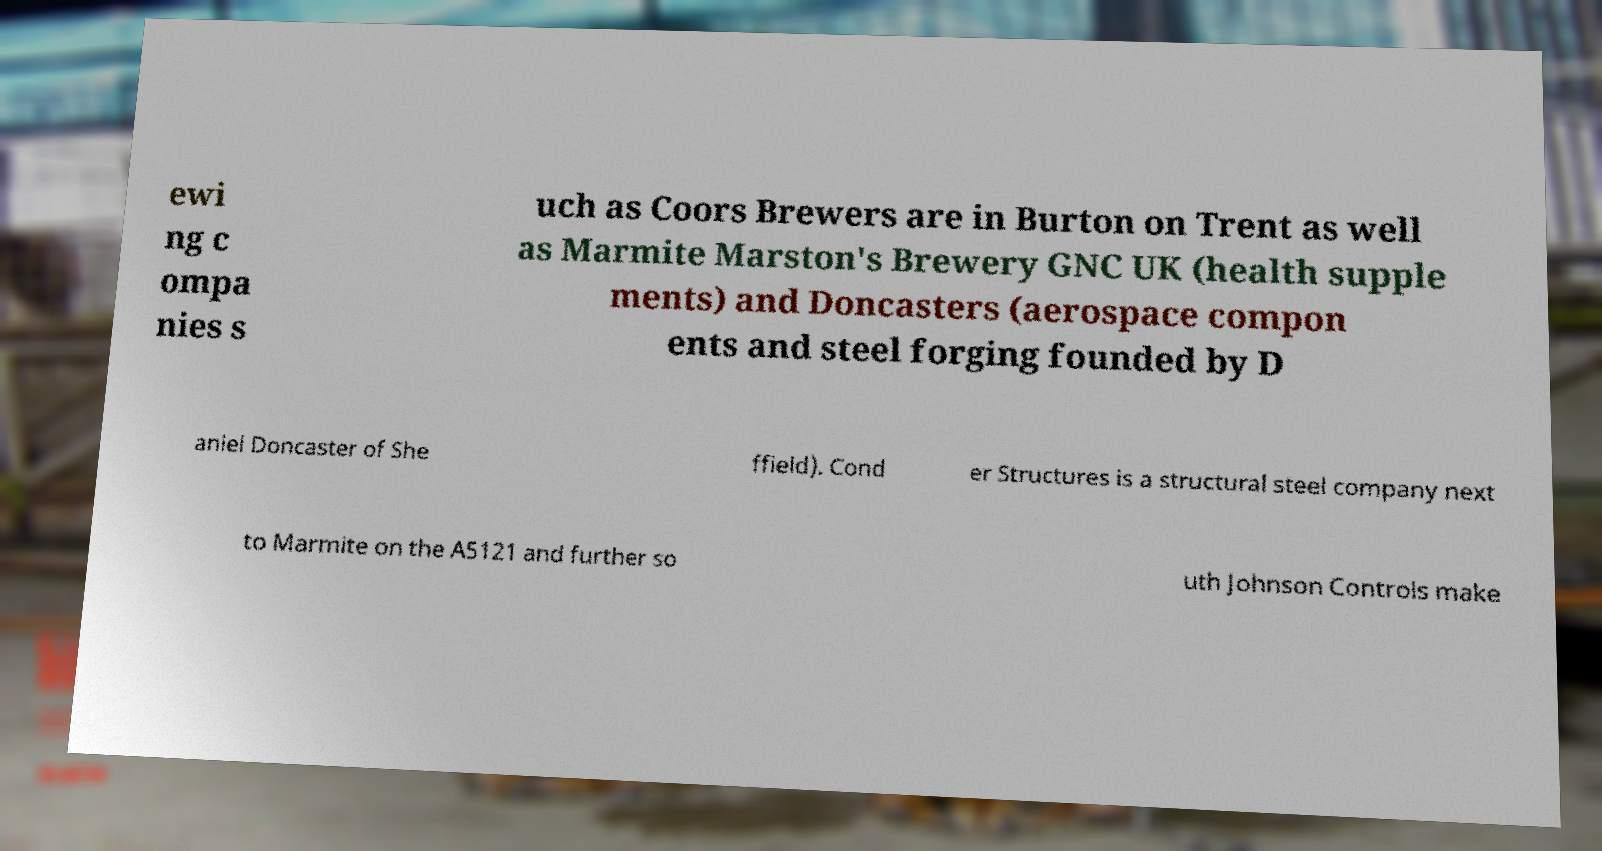There's text embedded in this image that I need extracted. Can you transcribe it verbatim? ewi ng c ompa nies s uch as Coors Brewers are in Burton on Trent as well as Marmite Marston's Brewery GNC UK (health supple ments) and Doncasters (aerospace compon ents and steel forging founded by D aniel Doncaster of She ffield). Cond er Structures is a structural steel company next to Marmite on the A5121 and further so uth Johnson Controls make 